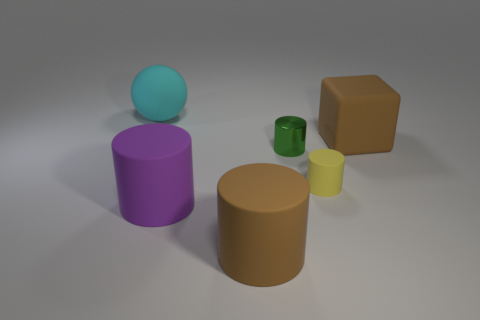Add 2 large red rubber objects. How many objects exist? 8 Subtract all cubes. How many objects are left? 5 Subtract 0 purple cubes. How many objects are left? 6 Subtract all large matte things. Subtract all big brown things. How many objects are left? 0 Add 4 large matte cubes. How many large matte cubes are left? 5 Add 6 brown rubber things. How many brown rubber things exist? 8 